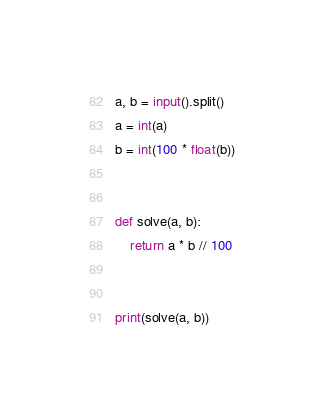<code> <loc_0><loc_0><loc_500><loc_500><_Python_>a, b = input().split()
a = int(a)
b = int(100 * float(b))
 
 
def solve(a, b):
    return a * b // 100
 
 
print(solve(a, b))</code> 